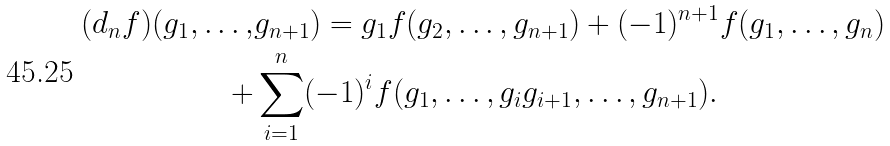<formula> <loc_0><loc_0><loc_500><loc_500>( d _ { n } f ) ( g _ { 1 } , \dots , & g _ { n + 1 } ) = g _ { 1 } f ( g _ { 2 } , \dots , g _ { n + 1 } ) + ( - 1 ) ^ { n + 1 } f ( g _ { 1 } , \dots , g _ { n } ) \\ + & \sum _ { i = 1 } ^ { n } ( - 1 ) ^ { i } f ( g _ { 1 } , \dots , g _ { i } g _ { i + 1 } , \dots , g _ { n + 1 } ) .</formula> 